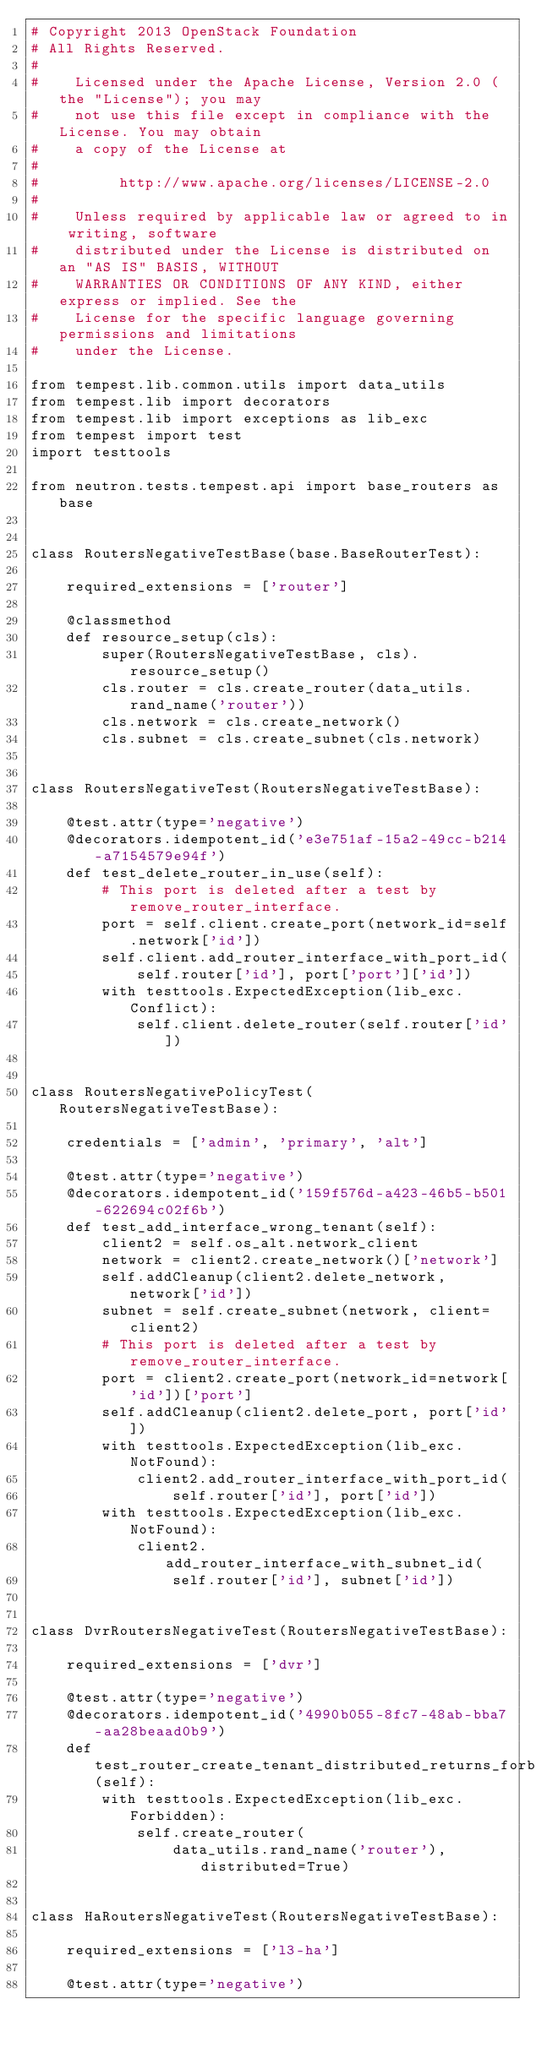Convert code to text. <code><loc_0><loc_0><loc_500><loc_500><_Python_># Copyright 2013 OpenStack Foundation
# All Rights Reserved.
#
#    Licensed under the Apache License, Version 2.0 (the "License"); you may
#    not use this file except in compliance with the License. You may obtain
#    a copy of the License at
#
#         http://www.apache.org/licenses/LICENSE-2.0
#
#    Unless required by applicable law or agreed to in writing, software
#    distributed under the License is distributed on an "AS IS" BASIS, WITHOUT
#    WARRANTIES OR CONDITIONS OF ANY KIND, either express or implied. See the
#    License for the specific language governing permissions and limitations
#    under the License.

from tempest.lib.common.utils import data_utils
from tempest.lib import decorators
from tempest.lib import exceptions as lib_exc
from tempest import test
import testtools

from neutron.tests.tempest.api import base_routers as base


class RoutersNegativeTestBase(base.BaseRouterTest):

    required_extensions = ['router']

    @classmethod
    def resource_setup(cls):
        super(RoutersNegativeTestBase, cls).resource_setup()
        cls.router = cls.create_router(data_utils.rand_name('router'))
        cls.network = cls.create_network()
        cls.subnet = cls.create_subnet(cls.network)


class RoutersNegativeTest(RoutersNegativeTestBase):

    @test.attr(type='negative')
    @decorators.idempotent_id('e3e751af-15a2-49cc-b214-a7154579e94f')
    def test_delete_router_in_use(self):
        # This port is deleted after a test by remove_router_interface.
        port = self.client.create_port(network_id=self.network['id'])
        self.client.add_router_interface_with_port_id(
            self.router['id'], port['port']['id'])
        with testtools.ExpectedException(lib_exc.Conflict):
            self.client.delete_router(self.router['id'])


class RoutersNegativePolicyTest(RoutersNegativeTestBase):

    credentials = ['admin', 'primary', 'alt']

    @test.attr(type='negative')
    @decorators.idempotent_id('159f576d-a423-46b5-b501-622694c02f6b')
    def test_add_interface_wrong_tenant(self):
        client2 = self.os_alt.network_client
        network = client2.create_network()['network']
        self.addCleanup(client2.delete_network, network['id'])
        subnet = self.create_subnet(network, client=client2)
        # This port is deleted after a test by remove_router_interface.
        port = client2.create_port(network_id=network['id'])['port']
        self.addCleanup(client2.delete_port, port['id'])
        with testtools.ExpectedException(lib_exc.NotFound):
            client2.add_router_interface_with_port_id(
                self.router['id'], port['id'])
        with testtools.ExpectedException(lib_exc.NotFound):
            client2.add_router_interface_with_subnet_id(
                self.router['id'], subnet['id'])


class DvrRoutersNegativeTest(RoutersNegativeTestBase):

    required_extensions = ['dvr']

    @test.attr(type='negative')
    @decorators.idempotent_id('4990b055-8fc7-48ab-bba7-aa28beaad0b9')
    def test_router_create_tenant_distributed_returns_forbidden(self):
        with testtools.ExpectedException(lib_exc.Forbidden):
            self.create_router(
                data_utils.rand_name('router'), distributed=True)


class HaRoutersNegativeTest(RoutersNegativeTestBase):

    required_extensions = ['l3-ha']

    @test.attr(type='negative')</code> 